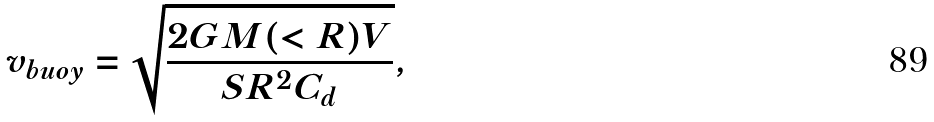<formula> <loc_0><loc_0><loc_500><loc_500>v _ { b u o y } = \sqrt { \frac { 2 G M ( < R ) V } { S R ^ { 2 } C _ { d } } } ,</formula> 